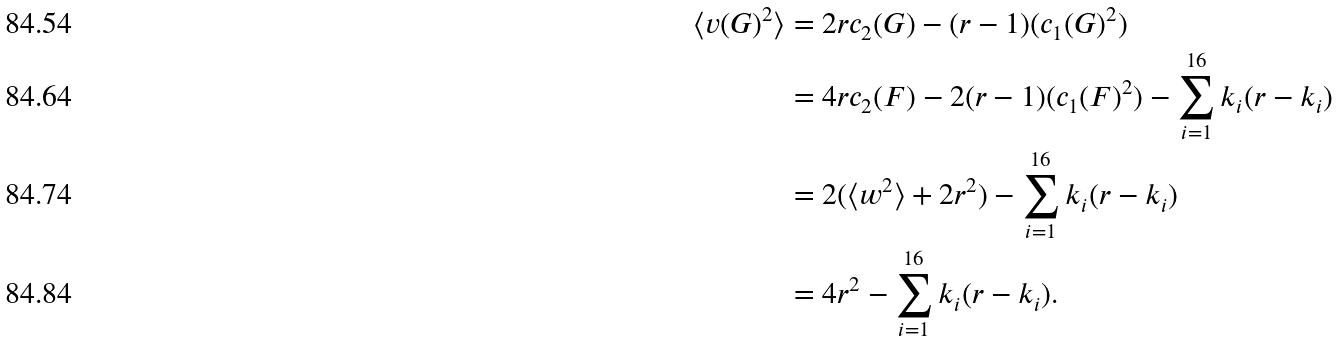Convert formula to latex. <formula><loc_0><loc_0><loc_500><loc_500>\langle v ( G ) ^ { 2 } \rangle & = 2 r c _ { 2 } ( G ) - ( r - 1 ) ( c _ { 1 } ( G ) ^ { 2 } ) \\ & = 4 r c _ { 2 } ( F ) - 2 ( r - 1 ) ( c _ { 1 } ( F ) ^ { 2 } ) - \sum _ { i = 1 } ^ { 1 6 } k _ { i } ( r - k _ { i } ) \\ & = 2 ( \langle w ^ { 2 } \rangle + 2 r ^ { 2 } ) - \sum _ { i = 1 } ^ { 1 6 } k _ { i } ( r - k _ { i } ) \\ & = 4 r ^ { 2 } - \sum _ { i = 1 } ^ { 1 6 } k _ { i } ( r - k _ { i } ) .</formula> 